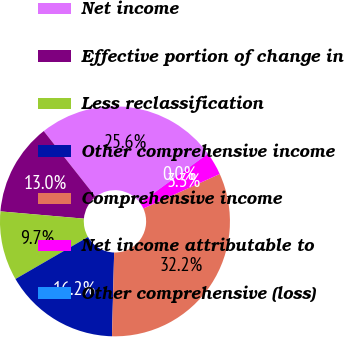<chart> <loc_0><loc_0><loc_500><loc_500><pie_chart><fcel>Net income<fcel>Effective portion of change in<fcel>Less reclassification<fcel>Other comprehensive income<fcel>Comprehensive income<fcel>Net income attributable to<fcel>Other comprehensive (loss)<nl><fcel>25.6%<fcel>12.99%<fcel>9.74%<fcel>16.23%<fcel>32.17%<fcel>3.26%<fcel>0.02%<nl></chart> 